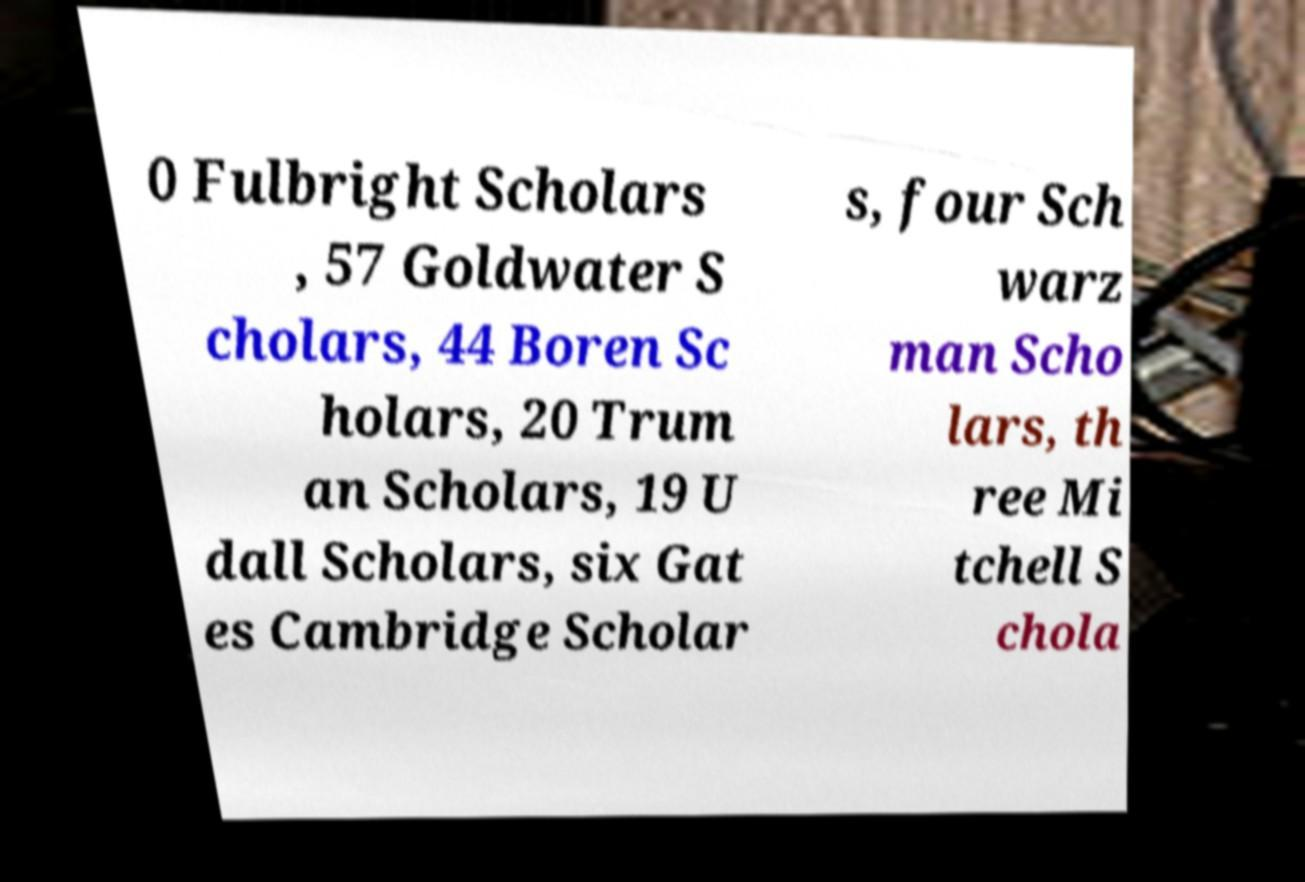Can you accurately transcribe the text from the provided image for me? 0 Fulbright Scholars , 57 Goldwater S cholars, 44 Boren Sc holars, 20 Trum an Scholars, 19 U dall Scholars, six Gat es Cambridge Scholar s, four Sch warz man Scho lars, th ree Mi tchell S chola 